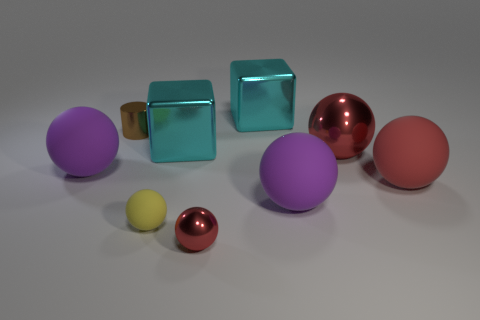Subtract all red spheres. How many were subtracted if there are1red spheres left? 2 Subtract all gray cubes. How many red balls are left? 3 Subtract all big metal spheres. How many spheres are left? 5 Subtract all purple balls. How many balls are left? 4 Add 1 big green matte objects. How many objects exist? 10 Subtract all spheres. How many objects are left? 3 Subtract all red spheres. Subtract all gray cylinders. How many spheres are left? 3 Subtract 1 red spheres. How many objects are left? 8 Subtract all large purple spheres. Subtract all tiny rubber spheres. How many objects are left? 6 Add 7 big purple balls. How many big purple balls are left? 9 